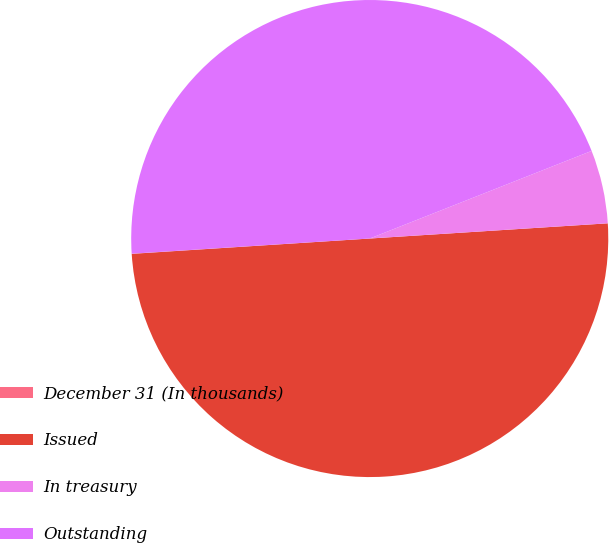Convert chart. <chart><loc_0><loc_0><loc_500><loc_500><pie_chart><fcel>December 31 (In thousands)<fcel>Issued<fcel>In treasury<fcel>Outstanding<nl><fcel>0.01%<fcel>49.99%<fcel>4.97%<fcel>45.03%<nl></chart> 